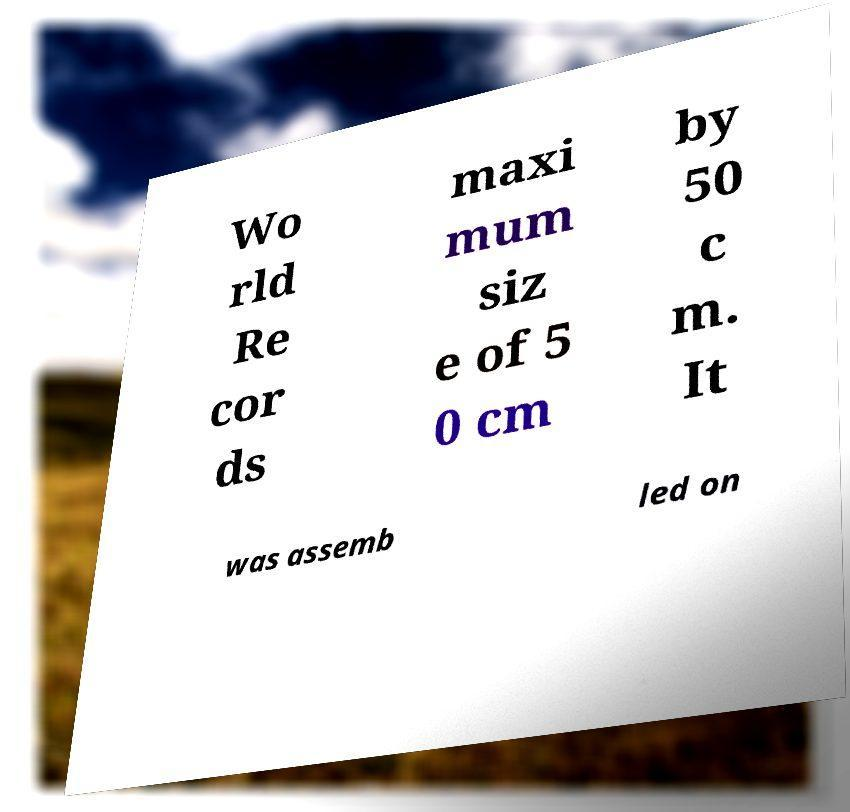Could you extract and type out the text from this image? Wo rld Re cor ds maxi mum siz e of 5 0 cm by 50 c m. It was assemb led on 